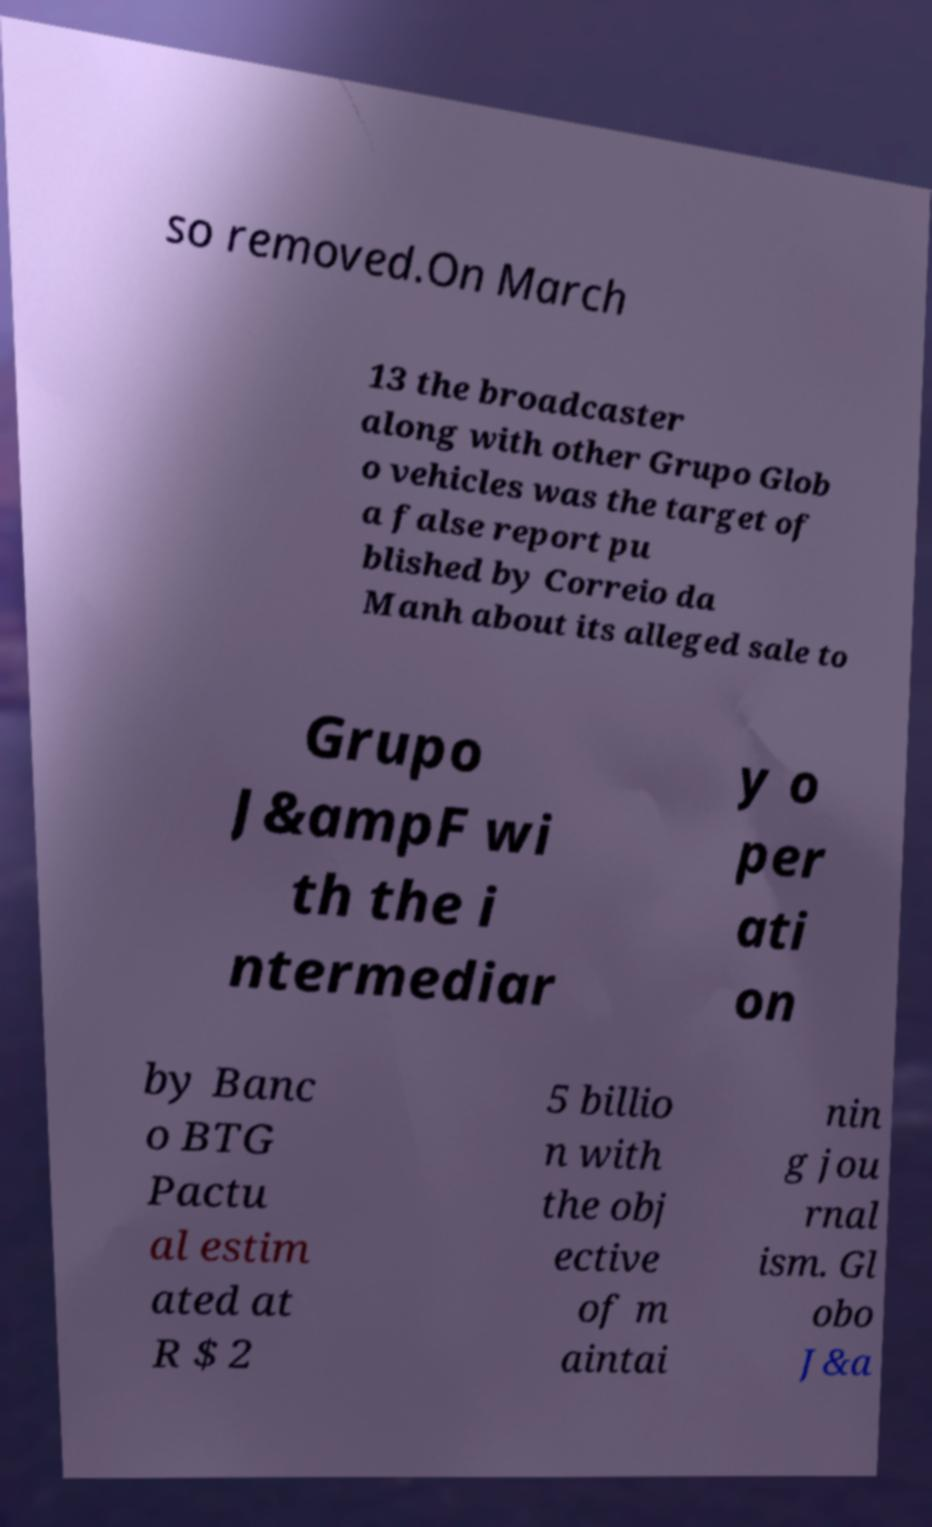Can you read and provide the text displayed in the image?This photo seems to have some interesting text. Can you extract and type it out for me? so removed.On March 13 the broadcaster along with other Grupo Glob o vehicles was the target of a false report pu blished by Correio da Manh about its alleged sale to Grupo J&ampF wi th the i ntermediar y o per ati on by Banc o BTG Pactu al estim ated at R $ 2 5 billio n with the obj ective of m aintai nin g jou rnal ism. Gl obo J&a 